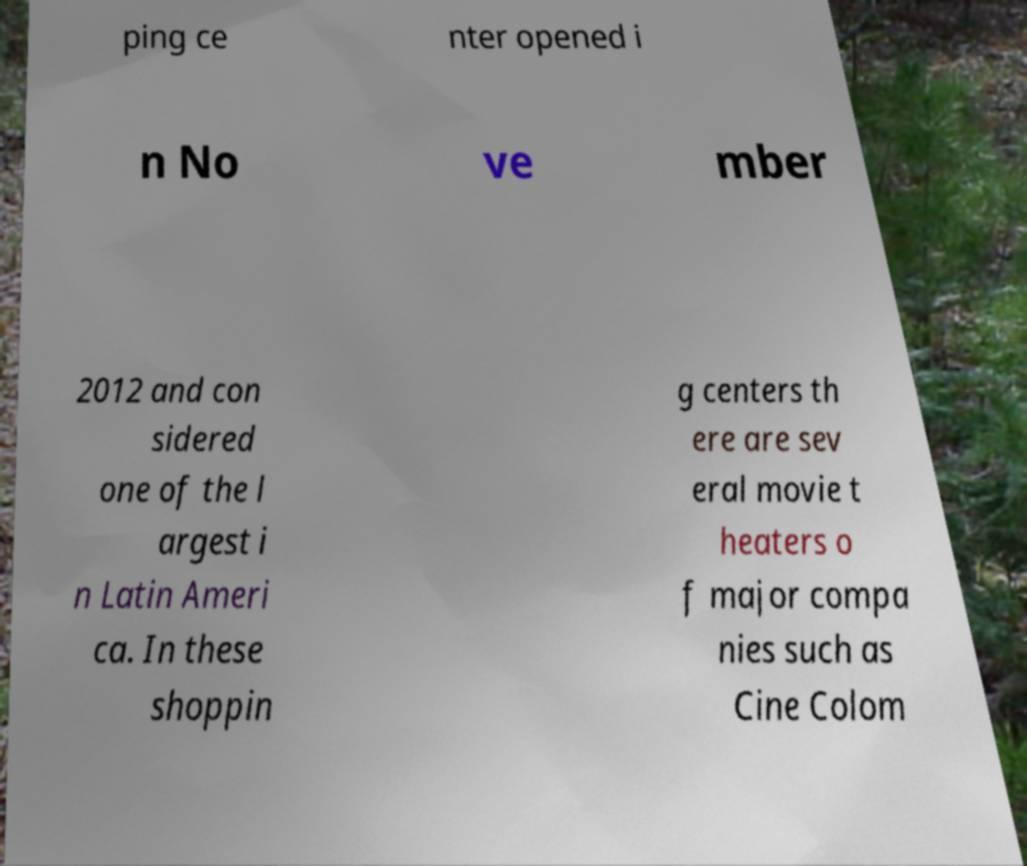Could you extract and type out the text from this image? ping ce nter opened i n No ve mber 2012 and con sidered one of the l argest i n Latin Ameri ca. In these shoppin g centers th ere are sev eral movie t heaters o f major compa nies such as Cine Colom 